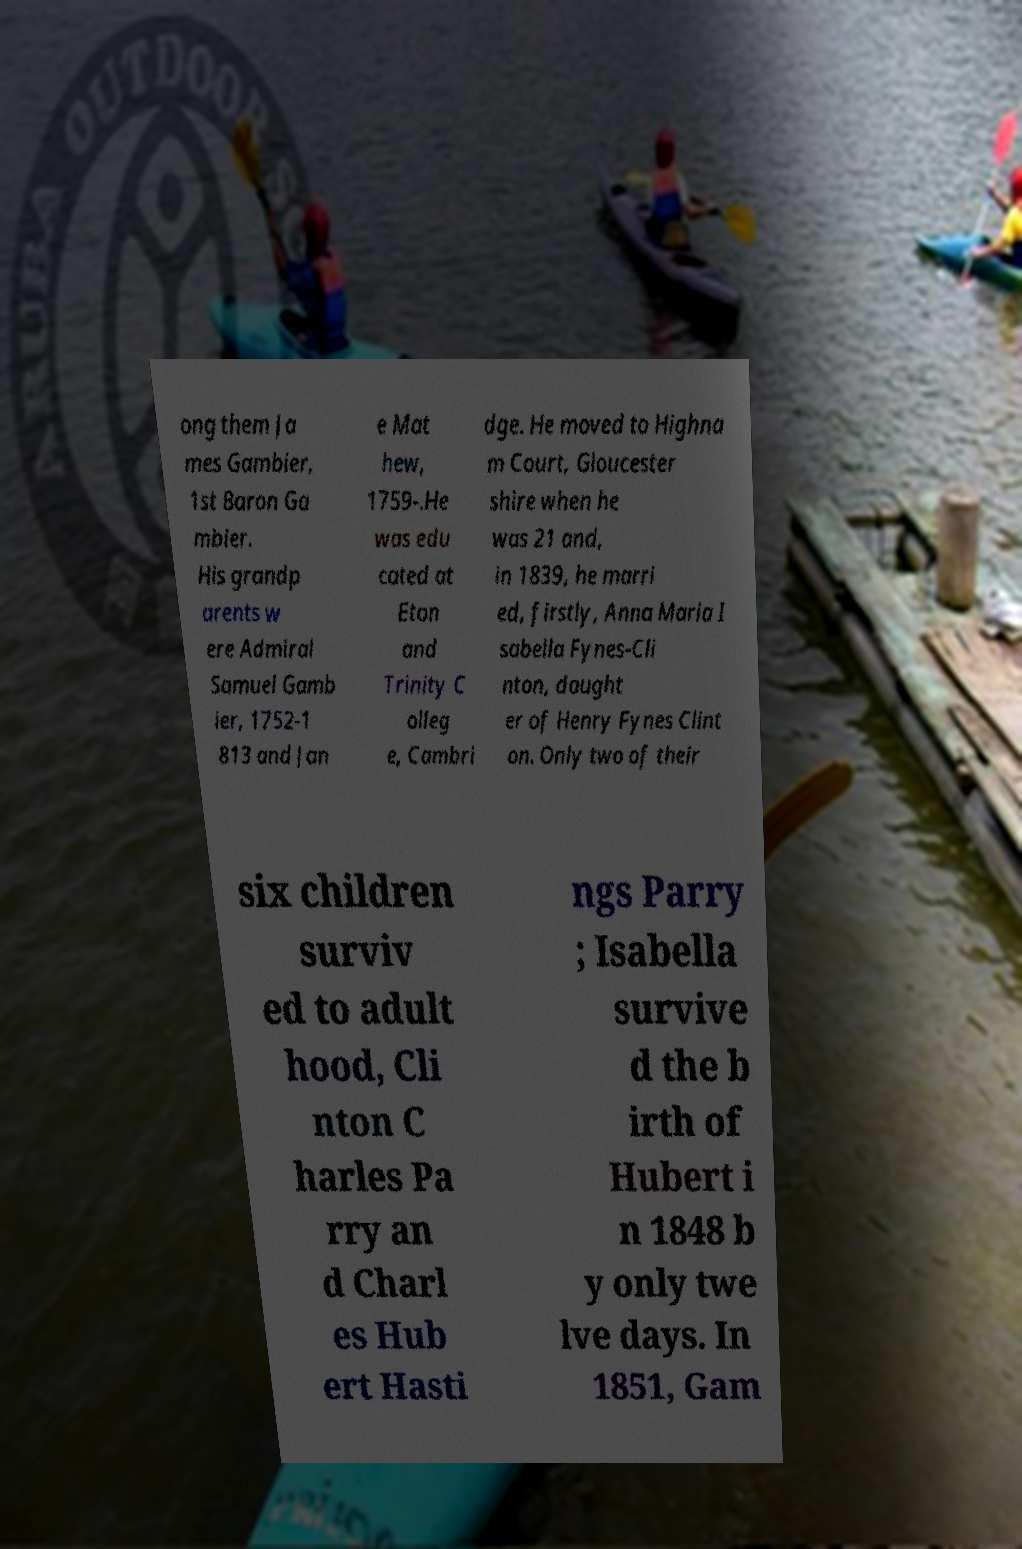Can you read and provide the text displayed in the image?This photo seems to have some interesting text. Can you extract and type it out for me? ong them Ja mes Gambier, 1st Baron Ga mbier. His grandp arents w ere Admiral Samuel Gamb ier, 1752-1 813 and Jan e Mat hew, 1759-.He was edu cated at Eton and Trinity C olleg e, Cambri dge. He moved to Highna m Court, Gloucester shire when he was 21 and, in 1839, he marri ed, firstly, Anna Maria I sabella Fynes-Cli nton, daught er of Henry Fynes Clint on. Only two of their six children surviv ed to adult hood, Cli nton C harles Pa rry an d Charl es Hub ert Hasti ngs Parry ; Isabella survive d the b irth of Hubert i n 1848 b y only twe lve days. In 1851, Gam 